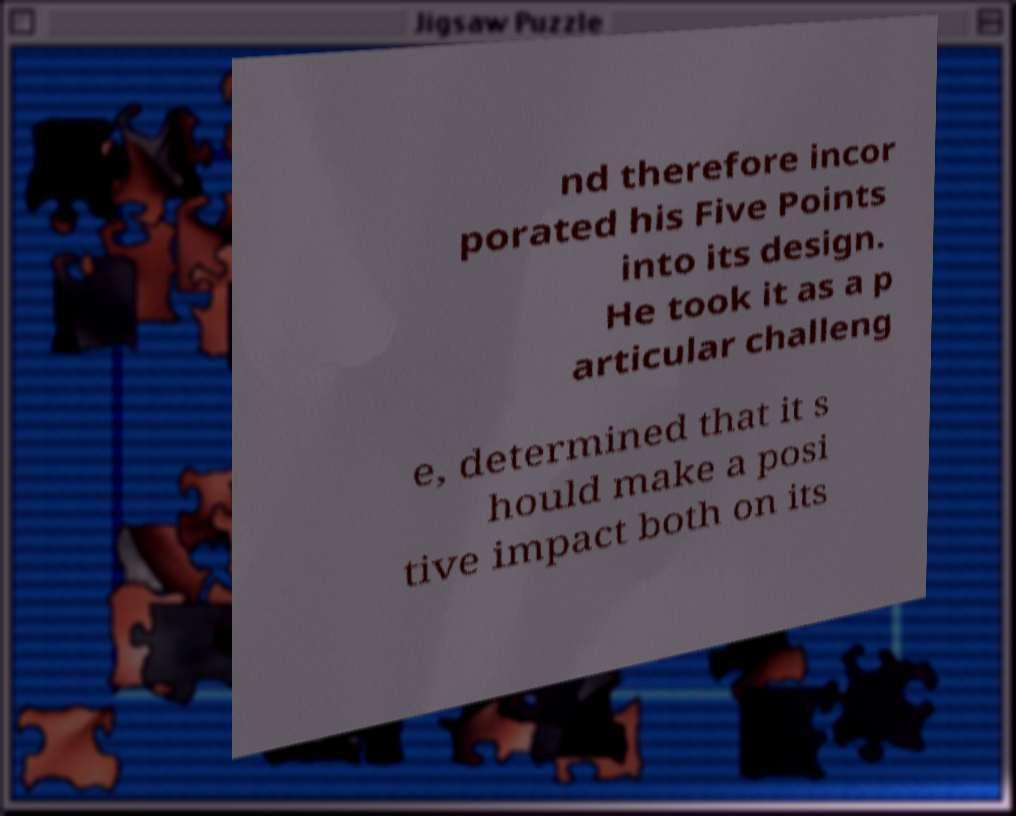Could you extract and type out the text from this image? nd therefore incor porated his Five Points into its design. He took it as a p articular challeng e, determined that it s hould make a posi tive impact both on its 